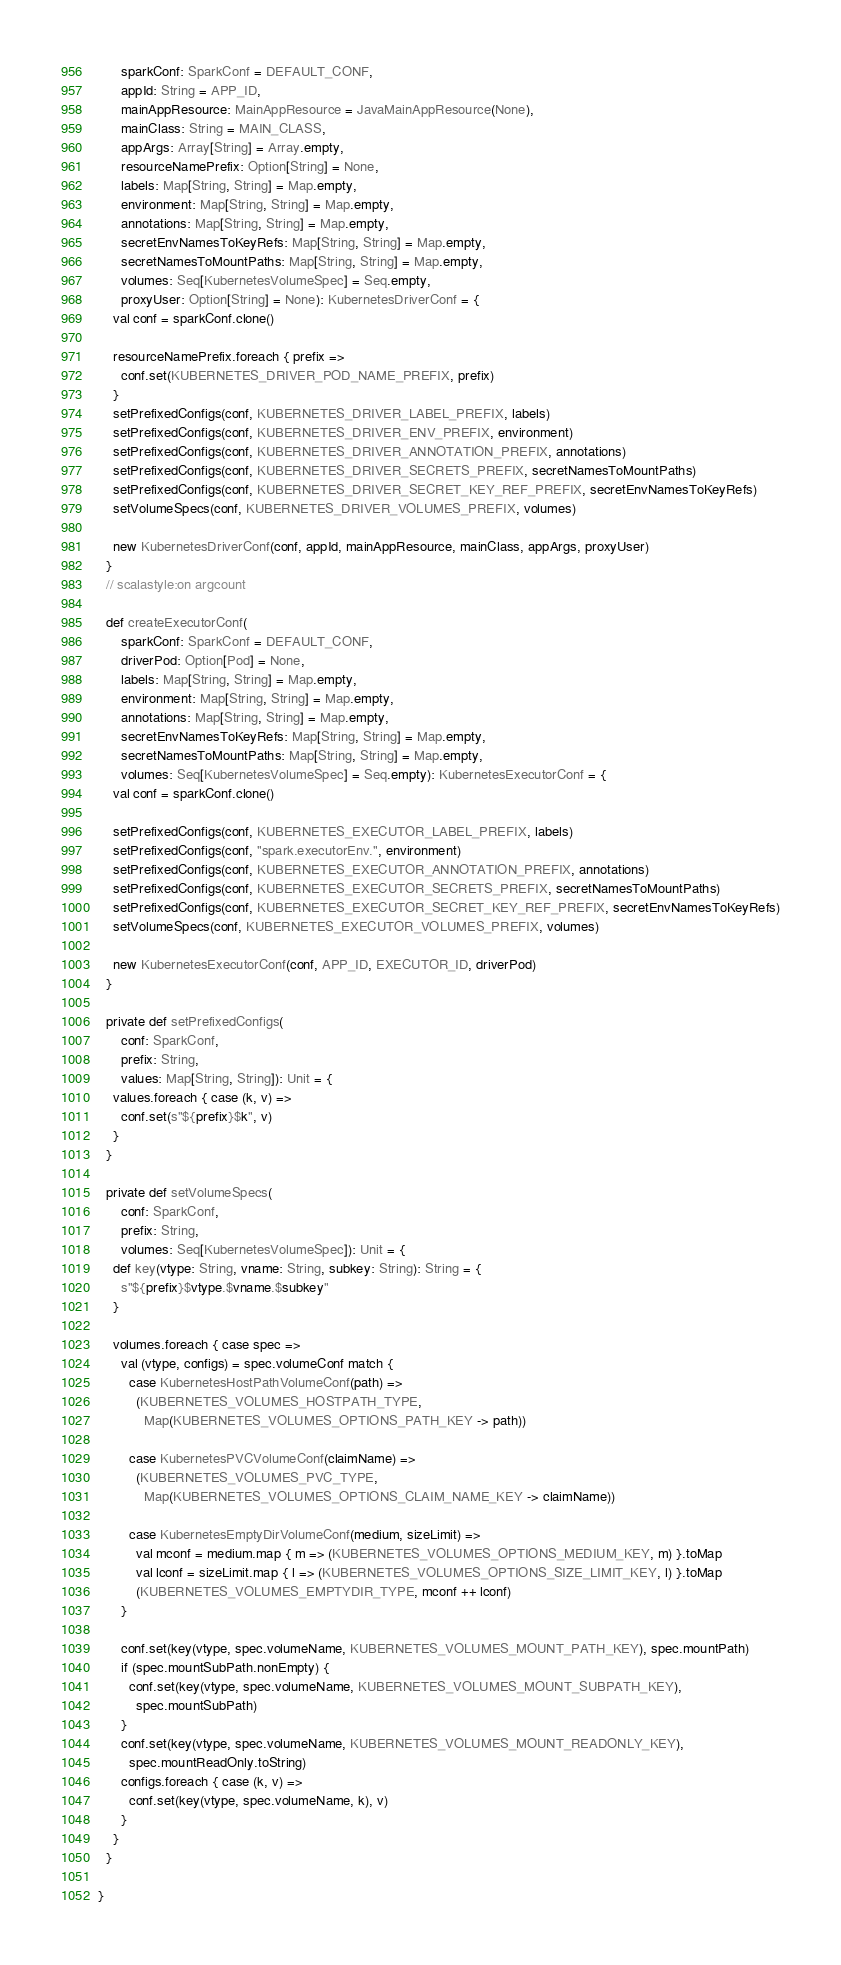<code> <loc_0><loc_0><loc_500><loc_500><_Scala_>      sparkConf: SparkConf = DEFAULT_CONF,
      appId: String = APP_ID,
      mainAppResource: MainAppResource = JavaMainAppResource(None),
      mainClass: String = MAIN_CLASS,
      appArgs: Array[String] = Array.empty,
      resourceNamePrefix: Option[String] = None,
      labels: Map[String, String] = Map.empty,
      environment: Map[String, String] = Map.empty,
      annotations: Map[String, String] = Map.empty,
      secretEnvNamesToKeyRefs: Map[String, String] = Map.empty,
      secretNamesToMountPaths: Map[String, String] = Map.empty,
      volumes: Seq[KubernetesVolumeSpec] = Seq.empty,
      proxyUser: Option[String] = None): KubernetesDriverConf = {
    val conf = sparkConf.clone()

    resourceNamePrefix.foreach { prefix =>
      conf.set(KUBERNETES_DRIVER_POD_NAME_PREFIX, prefix)
    }
    setPrefixedConfigs(conf, KUBERNETES_DRIVER_LABEL_PREFIX, labels)
    setPrefixedConfigs(conf, KUBERNETES_DRIVER_ENV_PREFIX, environment)
    setPrefixedConfigs(conf, KUBERNETES_DRIVER_ANNOTATION_PREFIX, annotations)
    setPrefixedConfigs(conf, KUBERNETES_DRIVER_SECRETS_PREFIX, secretNamesToMountPaths)
    setPrefixedConfigs(conf, KUBERNETES_DRIVER_SECRET_KEY_REF_PREFIX, secretEnvNamesToKeyRefs)
    setVolumeSpecs(conf, KUBERNETES_DRIVER_VOLUMES_PREFIX, volumes)

    new KubernetesDriverConf(conf, appId, mainAppResource, mainClass, appArgs, proxyUser)
  }
  // scalastyle:on argcount

  def createExecutorConf(
      sparkConf: SparkConf = DEFAULT_CONF,
      driverPod: Option[Pod] = None,
      labels: Map[String, String] = Map.empty,
      environment: Map[String, String] = Map.empty,
      annotations: Map[String, String] = Map.empty,
      secretEnvNamesToKeyRefs: Map[String, String] = Map.empty,
      secretNamesToMountPaths: Map[String, String] = Map.empty,
      volumes: Seq[KubernetesVolumeSpec] = Seq.empty): KubernetesExecutorConf = {
    val conf = sparkConf.clone()

    setPrefixedConfigs(conf, KUBERNETES_EXECUTOR_LABEL_PREFIX, labels)
    setPrefixedConfigs(conf, "spark.executorEnv.", environment)
    setPrefixedConfigs(conf, KUBERNETES_EXECUTOR_ANNOTATION_PREFIX, annotations)
    setPrefixedConfigs(conf, KUBERNETES_EXECUTOR_SECRETS_PREFIX, secretNamesToMountPaths)
    setPrefixedConfigs(conf, KUBERNETES_EXECUTOR_SECRET_KEY_REF_PREFIX, secretEnvNamesToKeyRefs)
    setVolumeSpecs(conf, KUBERNETES_EXECUTOR_VOLUMES_PREFIX, volumes)

    new KubernetesExecutorConf(conf, APP_ID, EXECUTOR_ID, driverPod)
  }

  private def setPrefixedConfigs(
      conf: SparkConf,
      prefix: String,
      values: Map[String, String]): Unit = {
    values.foreach { case (k, v) =>
      conf.set(s"${prefix}$k", v)
    }
  }

  private def setVolumeSpecs(
      conf: SparkConf,
      prefix: String,
      volumes: Seq[KubernetesVolumeSpec]): Unit = {
    def key(vtype: String, vname: String, subkey: String): String = {
      s"${prefix}$vtype.$vname.$subkey"
    }

    volumes.foreach { case spec =>
      val (vtype, configs) = spec.volumeConf match {
        case KubernetesHostPathVolumeConf(path) =>
          (KUBERNETES_VOLUMES_HOSTPATH_TYPE,
            Map(KUBERNETES_VOLUMES_OPTIONS_PATH_KEY -> path))

        case KubernetesPVCVolumeConf(claimName) =>
          (KUBERNETES_VOLUMES_PVC_TYPE,
            Map(KUBERNETES_VOLUMES_OPTIONS_CLAIM_NAME_KEY -> claimName))

        case KubernetesEmptyDirVolumeConf(medium, sizeLimit) =>
          val mconf = medium.map { m => (KUBERNETES_VOLUMES_OPTIONS_MEDIUM_KEY, m) }.toMap
          val lconf = sizeLimit.map { l => (KUBERNETES_VOLUMES_OPTIONS_SIZE_LIMIT_KEY, l) }.toMap
          (KUBERNETES_VOLUMES_EMPTYDIR_TYPE, mconf ++ lconf)
      }

      conf.set(key(vtype, spec.volumeName, KUBERNETES_VOLUMES_MOUNT_PATH_KEY), spec.mountPath)
      if (spec.mountSubPath.nonEmpty) {
        conf.set(key(vtype, spec.volumeName, KUBERNETES_VOLUMES_MOUNT_SUBPATH_KEY),
          spec.mountSubPath)
      }
      conf.set(key(vtype, spec.volumeName, KUBERNETES_VOLUMES_MOUNT_READONLY_KEY),
        spec.mountReadOnly.toString)
      configs.foreach { case (k, v) =>
        conf.set(key(vtype, spec.volumeName, k), v)
      }
    }
  }

}
</code> 